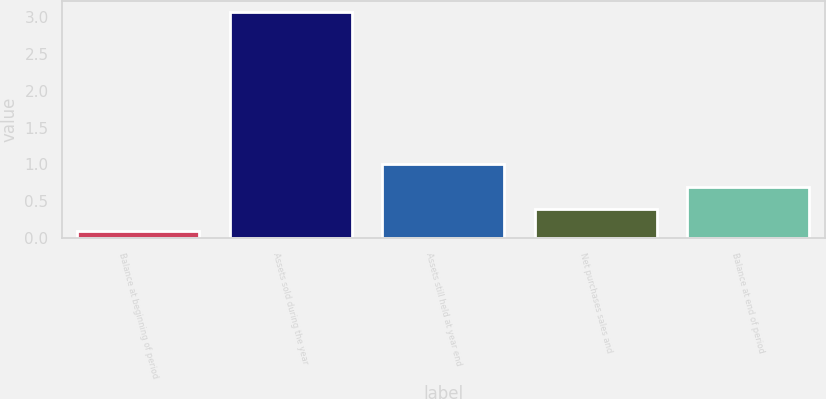<chart> <loc_0><loc_0><loc_500><loc_500><bar_chart><fcel>Balance at beginning of period<fcel>Assets sold during the year<fcel>Assets still held at year end<fcel>Net purchases sales and<fcel>Balance at end of period<nl><fcel>0.1<fcel>3.06<fcel>1<fcel>0.4<fcel>0.7<nl></chart> 